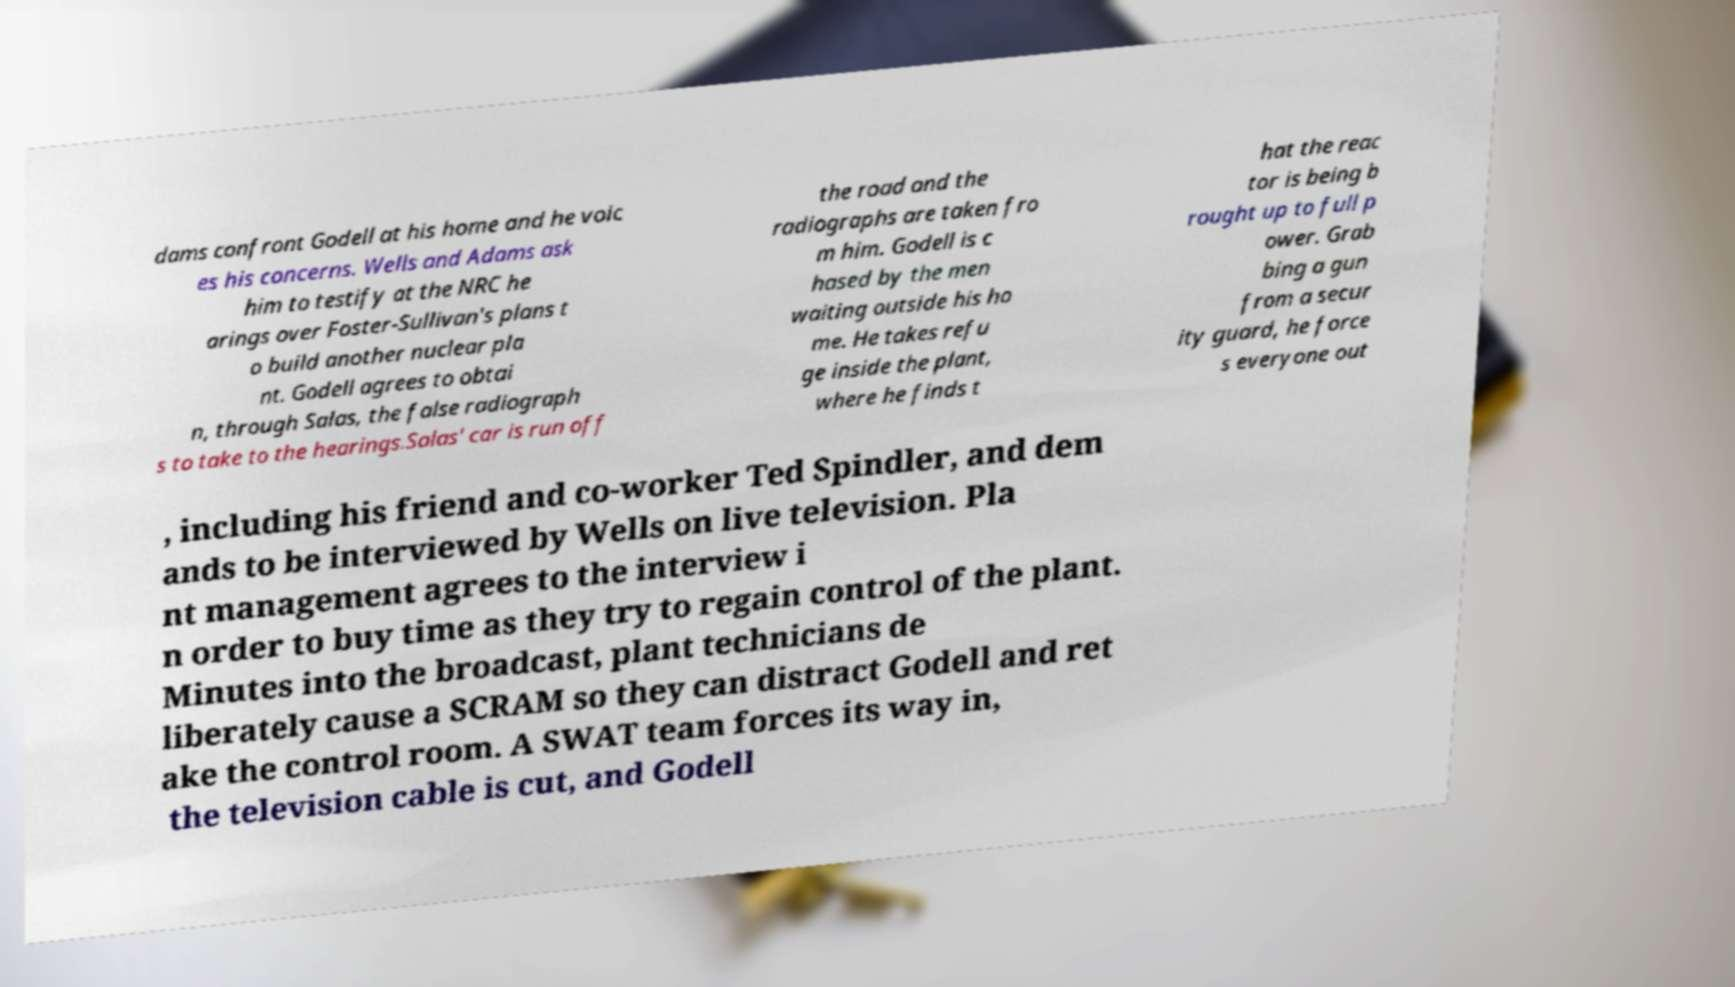There's text embedded in this image that I need extracted. Can you transcribe it verbatim? dams confront Godell at his home and he voic es his concerns. Wells and Adams ask him to testify at the NRC he arings over Foster-Sullivan's plans t o build another nuclear pla nt. Godell agrees to obtai n, through Salas, the false radiograph s to take to the hearings.Salas' car is run off the road and the radiographs are taken fro m him. Godell is c hased by the men waiting outside his ho me. He takes refu ge inside the plant, where he finds t hat the reac tor is being b rought up to full p ower. Grab bing a gun from a secur ity guard, he force s everyone out , including his friend and co-worker Ted Spindler, and dem ands to be interviewed by Wells on live television. Pla nt management agrees to the interview i n order to buy time as they try to regain control of the plant. Minutes into the broadcast, plant technicians de liberately cause a SCRAM so they can distract Godell and ret ake the control room. A SWAT team forces its way in, the television cable is cut, and Godell 